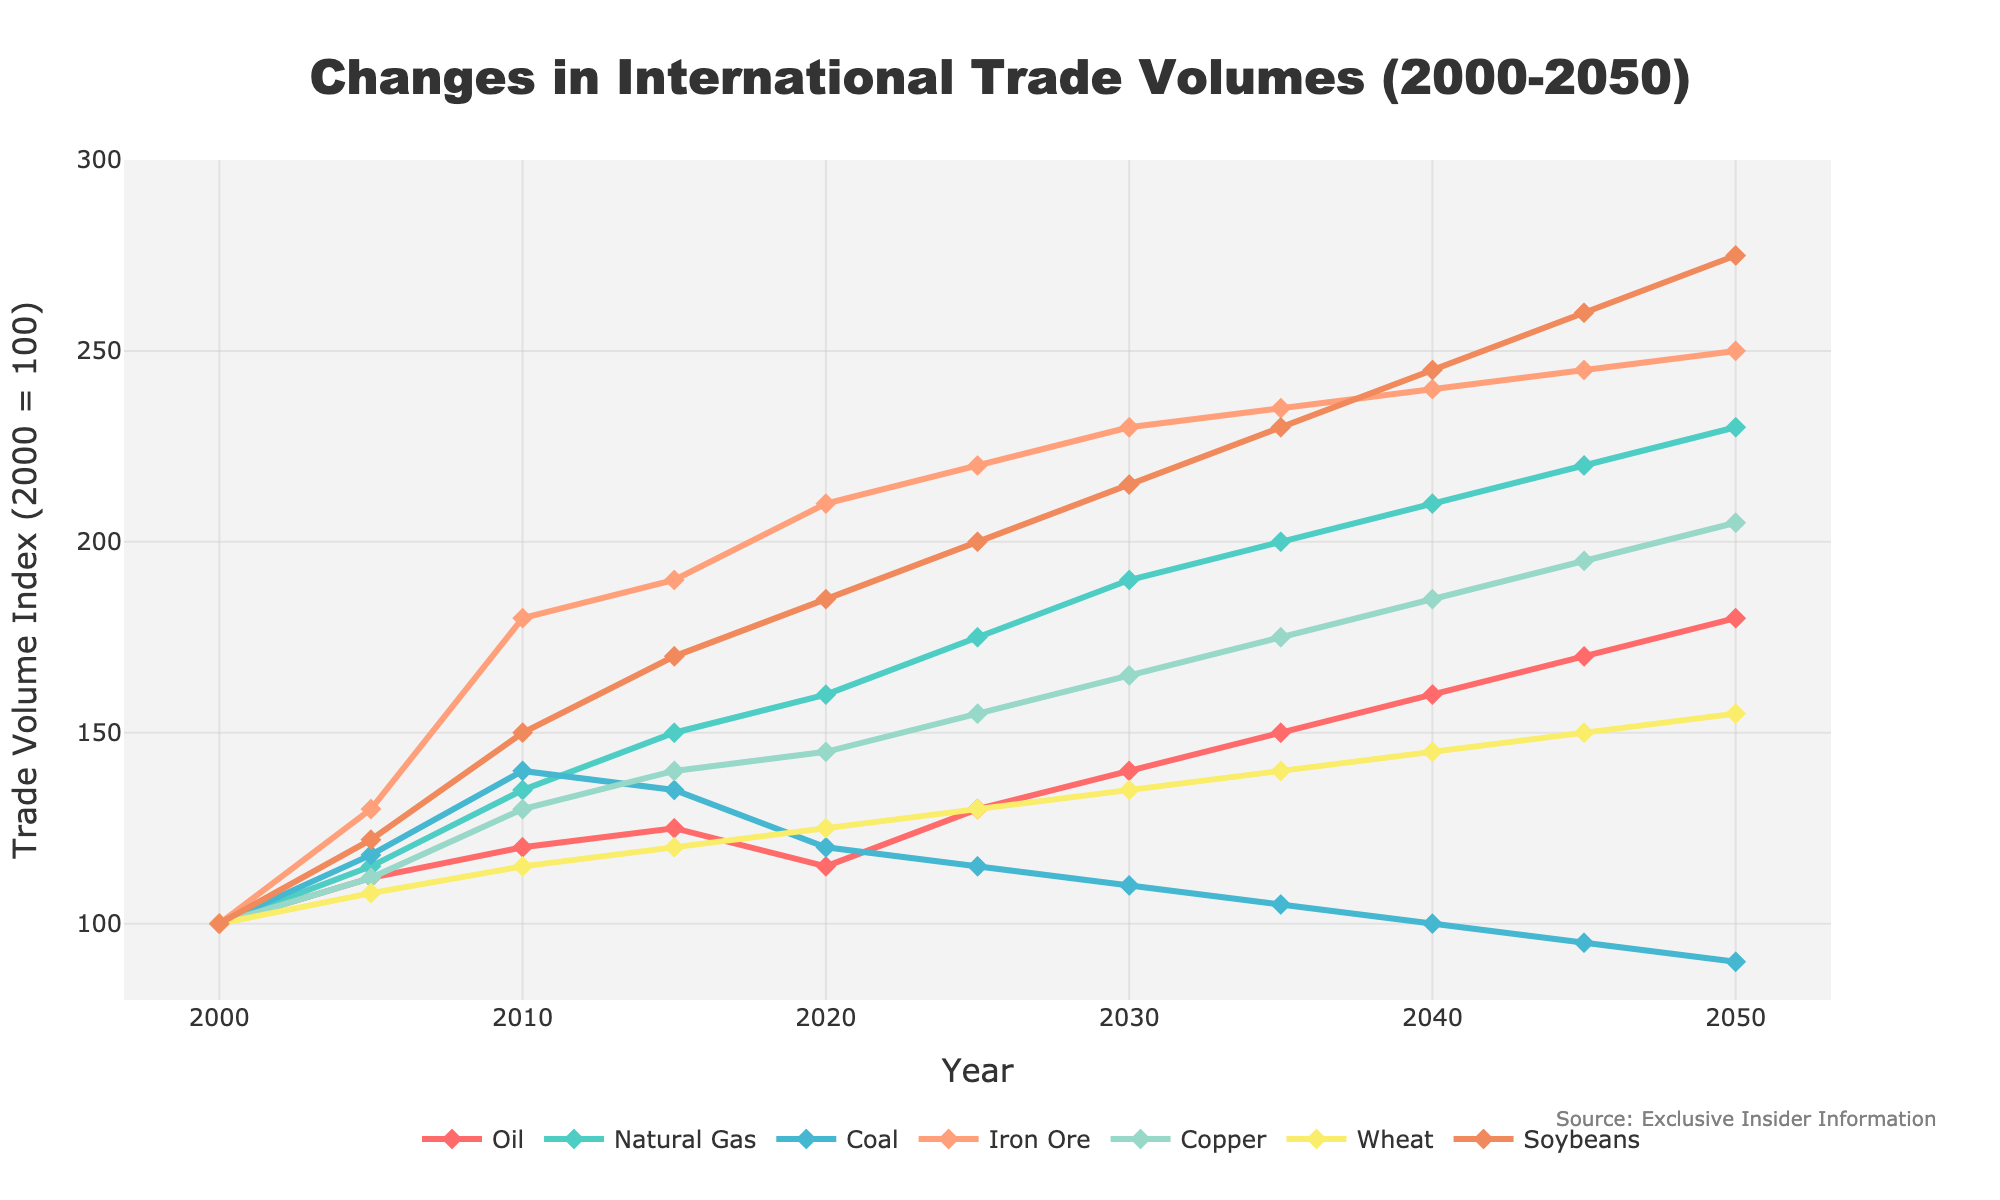Which commodity has the highest trade volume index in 2020? The figure shows the trade volume index for each commodity on the y-axis. In 2020, Iron Ore has the highest index, visualized by the height of the curve.
Answer: Iron Ore What is the overall trend for oil trade volumes from 2000 to 2050? The trendline for oil starts at 100 in 2000 and steadily increases to 180 by 2050. This indicates that oil trade volumes have an overall increasing trend.
Answer: Increasing Which two commodities have shown a decreasing trend since 2005? By observing the trendlines, Coal and Oil have shown a decreasing or fluctuating downward trend from 2005 onwards.
Answer: Coal and Oil Between 2030 and 2040, which commodity shows the sharpest increase in trade volume index? Among the commodities, Copper shows the steepest increase from around 165 in 2030 to approximately 185 in 2040.
Answer: Copper Compare the trade volume index of Wheat and Soybeans in the year 2015. Which commodity has a higher index? In 2015, the trade volume index for Wheat is around 120, whereas for Soybeans it is around 170. Thus, Soybeans have a higher index than Wheat.
Answer: Soybeans What is the average trade volume index of Natural Gas from 2020 to 2050? To find the average, compute the mean of the data points: (160 + 175 + 190 + 200 + 210 + 220 + 230) / 7 = 198.57 (rounded to two decimal places).
Answer: 198.57 By how much does the trade volume index of Copper change from 2020 to 2040? The trade volume index of Copper in 2020 is around 145, and it increases to approximately 185 in 2040. The difference is 185 - 145 = 40.
Answer: 40 Which two commodities have the closest trade volumes in 2050? In 2050, Wheat has an index of around 155, and Natural Gas has an index of around 230. The two closest commodities within that year are Wheat and Copper, with indices of around 155 and 205, respectively.
Answer: Wheat and Copper What is the color used to represent Coal in the figure? By looking at the color coding of lines, Coal is represented with the color orange.
Answer: Orange From 2000 to 2050, which commodity shows the most significant overall growth in trade volume index? Through visual inspection, Copper exhibits the most significant overall growth, going from 100 in 2000 to 205 in 2050, displaying a growth of 105 points.
Answer: Copper 